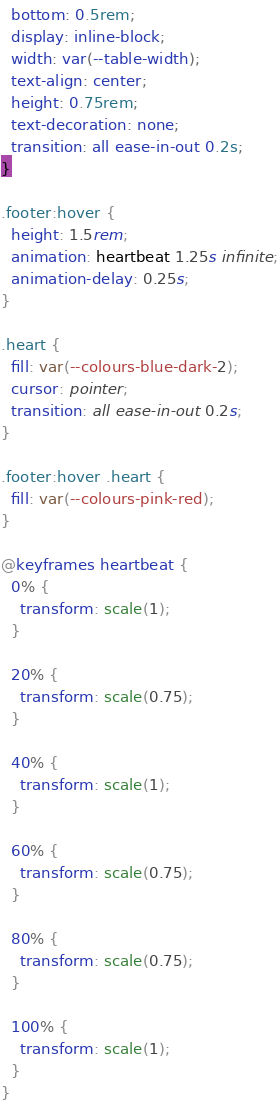<code> <loc_0><loc_0><loc_500><loc_500><_CSS_>  bottom: 0.5rem;
  display: inline-block;
  width: var(--table-width);
  text-align: center;
  height: 0.75rem;
  text-decoration: none;
  transition: all ease-in-out 0.2s;
}

.footer:hover {
  height: 1.5rem;
  animation: heartbeat 1.25s infinite;
  animation-delay: 0.25s;
}

.heart {
  fill: var(--colours-blue-dark-2);
  cursor: pointer;
  transition: all ease-in-out 0.2s;
}

.footer:hover .heart {
  fill: var(--colours-pink-red);
}

@keyframes heartbeat {
  0% {
    transform: scale(1);
  }

  20% {
    transform: scale(0.75);
  }

  40% {
    transform: scale(1);
  }

  60% {
    transform: scale(0.75);
  }

  80% {
    transform: scale(0.75);
  }

  100% {
    transform: scale(1);
  }
}
</code> 